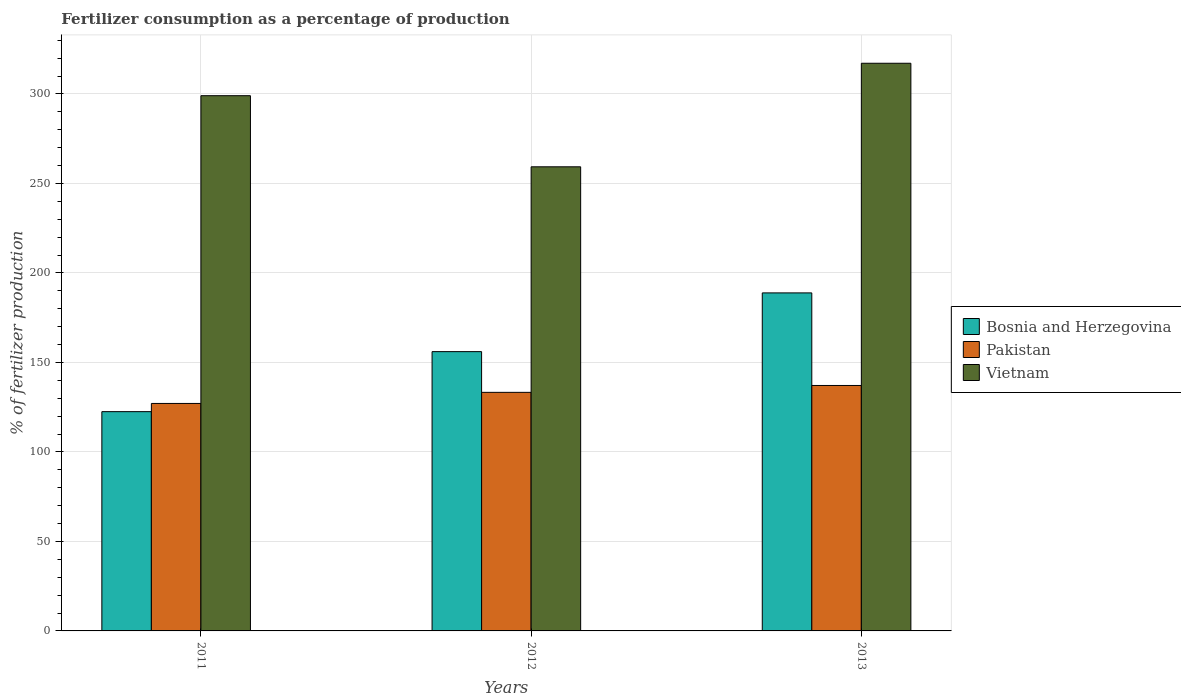How many groups of bars are there?
Provide a succinct answer. 3. How many bars are there on the 1st tick from the left?
Ensure brevity in your answer.  3. How many bars are there on the 1st tick from the right?
Provide a succinct answer. 3. What is the label of the 3rd group of bars from the left?
Keep it short and to the point. 2013. What is the percentage of fertilizers consumed in Bosnia and Herzegovina in 2012?
Offer a very short reply. 156.04. Across all years, what is the maximum percentage of fertilizers consumed in Vietnam?
Your answer should be very brief. 317.14. Across all years, what is the minimum percentage of fertilizers consumed in Pakistan?
Your response must be concise. 127.09. In which year was the percentage of fertilizers consumed in Vietnam minimum?
Ensure brevity in your answer.  2012. What is the total percentage of fertilizers consumed in Vietnam in the graph?
Provide a succinct answer. 875.45. What is the difference between the percentage of fertilizers consumed in Bosnia and Herzegovina in 2011 and that in 2013?
Your answer should be compact. -66.35. What is the difference between the percentage of fertilizers consumed in Vietnam in 2012 and the percentage of fertilizers consumed in Bosnia and Herzegovina in 2013?
Your answer should be compact. 70.45. What is the average percentage of fertilizers consumed in Pakistan per year?
Your response must be concise. 132.5. In the year 2013, what is the difference between the percentage of fertilizers consumed in Bosnia and Herzegovina and percentage of fertilizers consumed in Vietnam?
Offer a terse response. -128.3. In how many years, is the percentage of fertilizers consumed in Bosnia and Herzegovina greater than 150 %?
Your answer should be very brief. 2. What is the ratio of the percentage of fertilizers consumed in Pakistan in 2012 to that in 2013?
Make the answer very short. 0.97. What is the difference between the highest and the second highest percentage of fertilizers consumed in Bosnia and Herzegovina?
Provide a succinct answer. 32.81. What is the difference between the highest and the lowest percentage of fertilizers consumed in Bosnia and Herzegovina?
Ensure brevity in your answer.  66.35. In how many years, is the percentage of fertilizers consumed in Vietnam greater than the average percentage of fertilizers consumed in Vietnam taken over all years?
Give a very brief answer. 2. Is the sum of the percentage of fertilizers consumed in Vietnam in 2012 and 2013 greater than the maximum percentage of fertilizers consumed in Bosnia and Herzegovina across all years?
Your response must be concise. Yes. What does the 3rd bar from the left in 2013 represents?
Offer a very short reply. Vietnam. What does the 2nd bar from the right in 2011 represents?
Provide a short and direct response. Pakistan. Are all the bars in the graph horizontal?
Your answer should be very brief. No. How many years are there in the graph?
Provide a succinct answer. 3. Where does the legend appear in the graph?
Your answer should be compact. Center right. How many legend labels are there?
Make the answer very short. 3. How are the legend labels stacked?
Offer a very short reply. Vertical. What is the title of the graph?
Your response must be concise. Fertilizer consumption as a percentage of production. What is the label or title of the X-axis?
Give a very brief answer. Years. What is the label or title of the Y-axis?
Ensure brevity in your answer.  % of fertilizer production. What is the % of fertilizer production in Bosnia and Herzegovina in 2011?
Provide a short and direct response. 122.5. What is the % of fertilizer production of Pakistan in 2011?
Your answer should be compact. 127.09. What is the % of fertilizer production in Vietnam in 2011?
Your answer should be compact. 299.02. What is the % of fertilizer production in Bosnia and Herzegovina in 2012?
Your response must be concise. 156.04. What is the % of fertilizer production in Pakistan in 2012?
Provide a short and direct response. 133.28. What is the % of fertilizer production in Vietnam in 2012?
Your answer should be compact. 259.29. What is the % of fertilizer production in Bosnia and Herzegovina in 2013?
Your response must be concise. 188.85. What is the % of fertilizer production in Pakistan in 2013?
Give a very brief answer. 137.12. What is the % of fertilizer production in Vietnam in 2013?
Offer a very short reply. 317.14. Across all years, what is the maximum % of fertilizer production in Bosnia and Herzegovina?
Ensure brevity in your answer.  188.85. Across all years, what is the maximum % of fertilizer production of Pakistan?
Ensure brevity in your answer.  137.12. Across all years, what is the maximum % of fertilizer production in Vietnam?
Keep it short and to the point. 317.14. Across all years, what is the minimum % of fertilizer production in Bosnia and Herzegovina?
Provide a short and direct response. 122.5. Across all years, what is the minimum % of fertilizer production in Pakistan?
Provide a succinct answer. 127.09. Across all years, what is the minimum % of fertilizer production of Vietnam?
Offer a very short reply. 259.29. What is the total % of fertilizer production of Bosnia and Herzegovina in the graph?
Offer a very short reply. 467.38. What is the total % of fertilizer production of Pakistan in the graph?
Offer a terse response. 397.5. What is the total % of fertilizer production of Vietnam in the graph?
Make the answer very short. 875.45. What is the difference between the % of fertilizer production of Bosnia and Herzegovina in 2011 and that in 2012?
Offer a very short reply. -33.54. What is the difference between the % of fertilizer production of Pakistan in 2011 and that in 2012?
Provide a short and direct response. -6.19. What is the difference between the % of fertilizer production in Vietnam in 2011 and that in 2012?
Your response must be concise. 39.72. What is the difference between the % of fertilizer production in Bosnia and Herzegovina in 2011 and that in 2013?
Keep it short and to the point. -66.35. What is the difference between the % of fertilizer production in Pakistan in 2011 and that in 2013?
Provide a short and direct response. -10.03. What is the difference between the % of fertilizer production of Vietnam in 2011 and that in 2013?
Your answer should be compact. -18.12. What is the difference between the % of fertilizer production of Bosnia and Herzegovina in 2012 and that in 2013?
Your response must be concise. -32.81. What is the difference between the % of fertilizer production in Pakistan in 2012 and that in 2013?
Give a very brief answer. -3.84. What is the difference between the % of fertilizer production of Vietnam in 2012 and that in 2013?
Provide a succinct answer. -57.85. What is the difference between the % of fertilizer production of Bosnia and Herzegovina in 2011 and the % of fertilizer production of Pakistan in 2012?
Ensure brevity in your answer.  -10.79. What is the difference between the % of fertilizer production of Bosnia and Herzegovina in 2011 and the % of fertilizer production of Vietnam in 2012?
Keep it short and to the point. -136.8. What is the difference between the % of fertilizer production in Pakistan in 2011 and the % of fertilizer production in Vietnam in 2012?
Keep it short and to the point. -132.2. What is the difference between the % of fertilizer production of Bosnia and Herzegovina in 2011 and the % of fertilizer production of Pakistan in 2013?
Give a very brief answer. -14.62. What is the difference between the % of fertilizer production of Bosnia and Herzegovina in 2011 and the % of fertilizer production of Vietnam in 2013?
Your answer should be compact. -194.64. What is the difference between the % of fertilizer production of Pakistan in 2011 and the % of fertilizer production of Vietnam in 2013?
Your answer should be very brief. -190.05. What is the difference between the % of fertilizer production of Bosnia and Herzegovina in 2012 and the % of fertilizer production of Pakistan in 2013?
Offer a very short reply. 18.91. What is the difference between the % of fertilizer production in Bosnia and Herzegovina in 2012 and the % of fertilizer production in Vietnam in 2013?
Your answer should be compact. -161.11. What is the difference between the % of fertilizer production of Pakistan in 2012 and the % of fertilizer production of Vietnam in 2013?
Provide a short and direct response. -183.86. What is the average % of fertilizer production in Bosnia and Herzegovina per year?
Give a very brief answer. 155.79. What is the average % of fertilizer production in Pakistan per year?
Provide a succinct answer. 132.5. What is the average % of fertilizer production of Vietnam per year?
Make the answer very short. 291.82. In the year 2011, what is the difference between the % of fertilizer production of Bosnia and Herzegovina and % of fertilizer production of Pakistan?
Offer a very short reply. -4.59. In the year 2011, what is the difference between the % of fertilizer production of Bosnia and Herzegovina and % of fertilizer production of Vietnam?
Ensure brevity in your answer.  -176.52. In the year 2011, what is the difference between the % of fertilizer production in Pakistan and % of fertilizer production in Vietnam?
Provide a succinct answer. -171.93. In the year 2012, what is the difference between the % of fertilizer production in Bosnia and Herzegovina and % of fertilizer production in Pakistan?
Offer a terse response. 22.75. In the year 2012, what is the difference between the % of fertilizer production of Bosnia and Herzegovina and % of fertilizer production of Vietnam?
Your response must be concise. -103.26. In the year 2012, what is the difference between the % of fertilizer production in Pakistan and % of fertilizer production in Vietnam?
Keep it short and to the point. -126.01. In the year 2013, what is the difference between the % of fertilizer production in Bosnia and Herzegovina and % of fertilizer production in Pakistan?
Your answer should be very brief. 51.72. In the year 2013, what is the difference between the % of fertilizer production in Bosnia and Herzegovina and % of fertilizer production in Vietnam?
Your response must be concise. -128.3. In the year 2013, what is the difference between the % of fertilizer production of Pakistan and % of fertilizer production of Vietnam?
Your response must be concise. -180.02. What is the ratio of the % of fertilizer production of Bosnia and Herzegovina in 2011 to that in 2012?
Your answer should be compact. 0.79. What is the ratio of the % of fertilizer production in Pakistan in 2011 to that in 2012?
Your response must be concise. 0.95. What is the ratio of the % of fertilizer production of Vietnam in 2011 to that in 2012?
Your answer should be very brief. 1.15. What is the ratio of the % of fertilizer production in Bosnia and Herzegovina in 2011 to that in 2013?
Give a very brief answer. 0.65. What is the ratio of the % of fertilizer production in Pakistan in 2011 to that in 2013?
Make the answer very short. 0.93. What is the ratio of the % of fertilizer production of Vietnam in 2011 to that in 2013?
Your answer should be very brief. 0.94. What is the ratio of the % of fertilizer production of Bosnia and Herzegovina in 2012 to that in 2013?
Offer a very short reply. 0.83. What is the ratio of the % of fertilizer production in Vietnam in 2012 to that in 2013?
Provide a succinct answer. 0.82. What is the difference between the highest and the second highest % of fertilizer production in Bosnia and Herzegovina?
Ensure brevity in your answer.  32.81. What is the difference between the highest and the second highest % of fertilizer production in Pakistan?
Keep it short and to the point. 3.84. What is the difference between the highest and the second highest % of fertilizer production of Vietnam?
Ensure brevity in your answer.  18.12. What is the difference between the highest and the lowest % of fertilizer production in Bosnia and Herzegovina?
Provide a short and direct response. 66.35. What is the difference between the highest and the lowest % of fertilizer production of Pakistan?
Provide a short and direct response. 10.03. What is the difference between the highest and the lowest % of fertilizer production of Vietnam?
Provide a short and direct response. 57.85. 